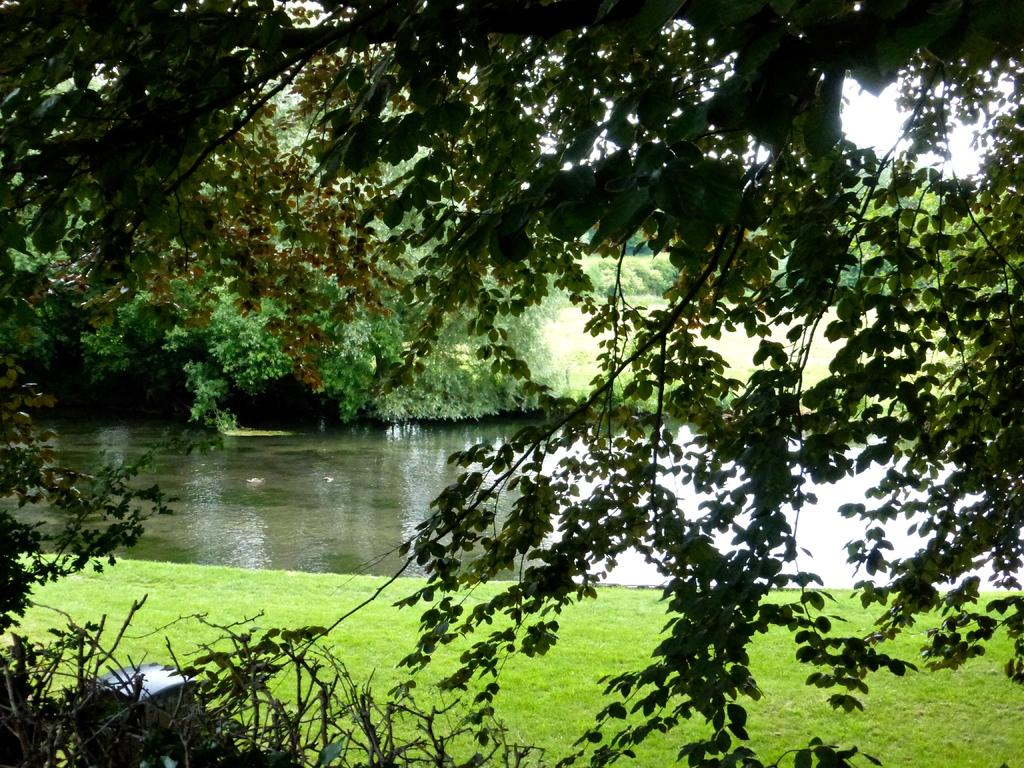What type of vegetation can be seen in the image? There are trees in the image. What is the ground surface like in the image? There is a grass surface in the image. What natural element is visible in the image? There is water visible in the image. What type of plants are located near the water in the image? There are plants beside the water in the image. What part of the sky can be seen in the image? The sky is partially visible in the image. How many turkeys can be seen in the image? There are no turkeys present in the image. What type of cannon is located near the water in the image? There is no cannon present in the image. 